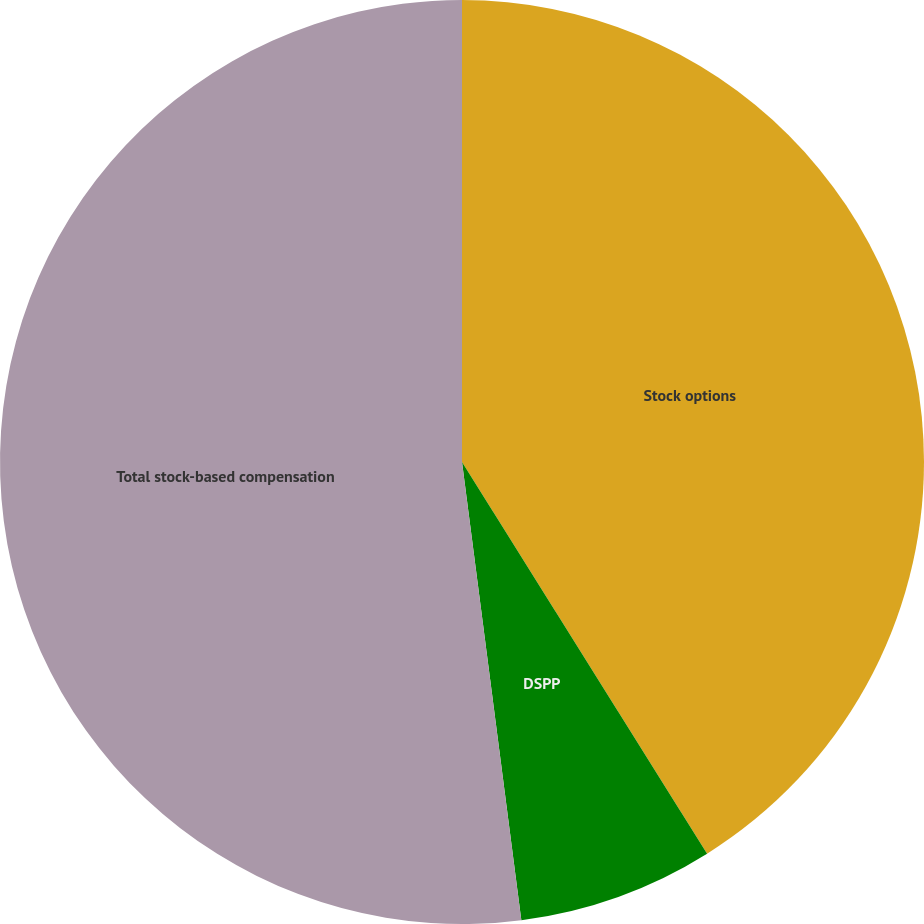Convert chart to OTSL. <chart><loc_0><loc_0><loc_500><loc_500><pie_chart><fcel>Stock options<fcel>DSPP<fcel>Total stock-based compensation<nl><fcel>41.1%<fcel>6.85%<fcel>52.05%<nl></chart> 